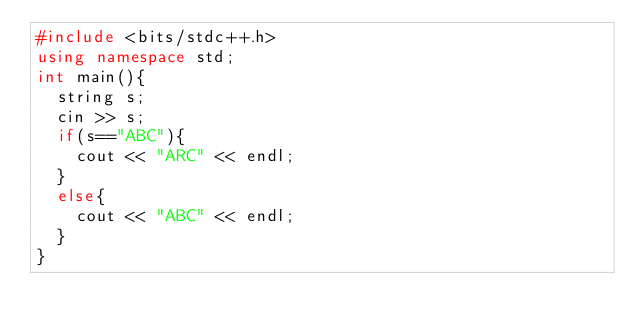<code> <loc_0><loc_0><loc_500><loc_500><_C++_>#include <bits/stdc++.h>
using namespace std;
int main(){
  string s;
  cin >> s;
  if(s=="ABC"){
    cout << "ARC" << endl;
  }
  else{
    cout << "ABC" << endl;
  }
}
</code> 